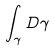<formula> <loc_0><loc_0><loc_500><loc_500>\int _ { \gamma } D \gamma</formula> 